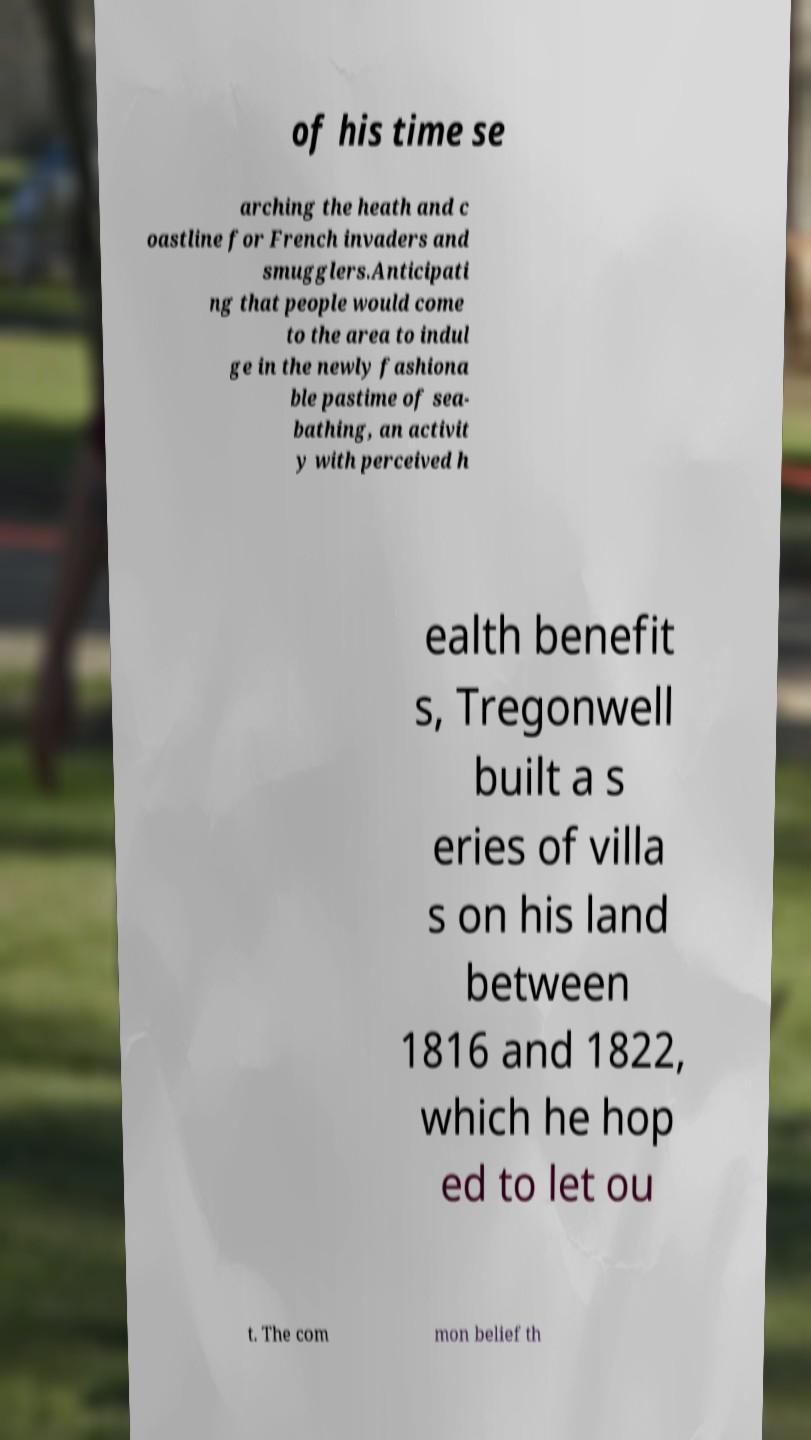There's text embedded in this image that I need extracted. Can you transcribe it verbatim? of his time se arching the heath and c oastline for French invaders and smugglers.Anticipati ng that people would come to the area to indul ge in the newly fashiona ble pastime of sea- bathing, an activit y with perceived h ealth benefit s, Tregonwell built a s eries of villa s on his land between 1816 and 1822, which he hop ed to let ou t. The com mon belief th 